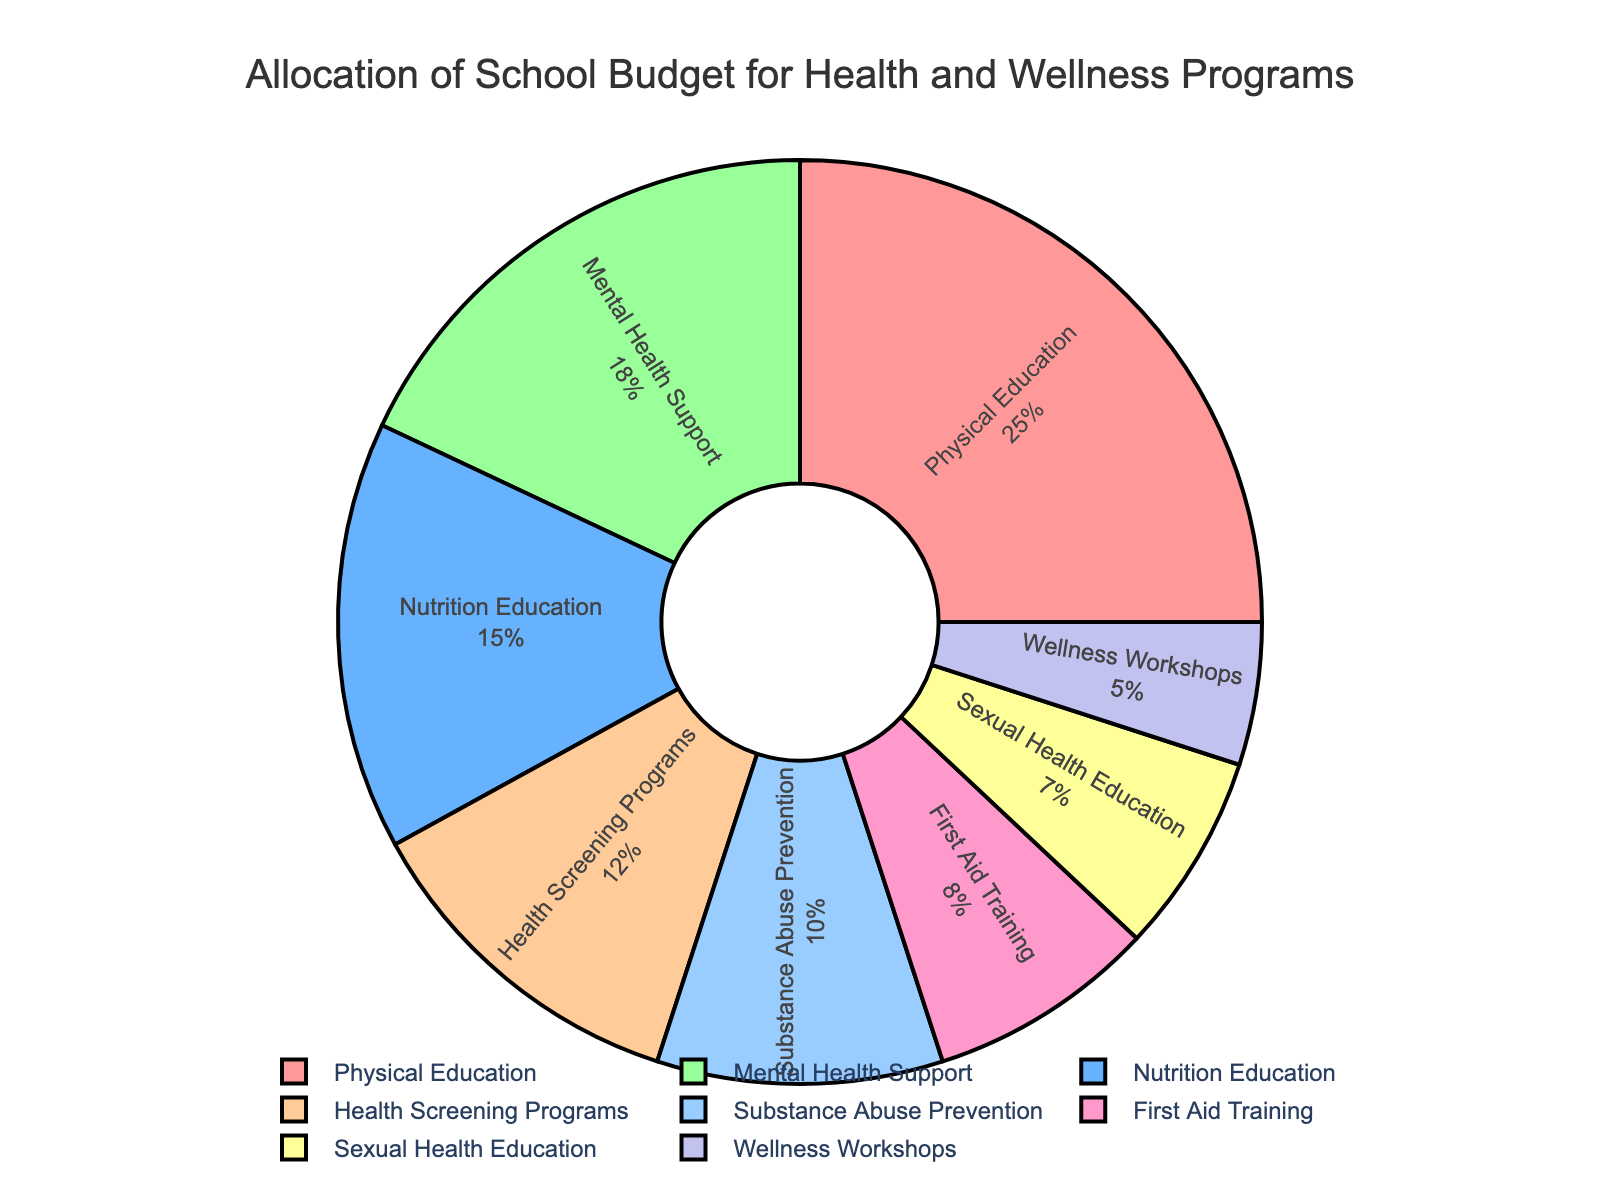What percentage of the school budget is allocated to Mental Health Support and Health Screening Programs combined? Add the percentages for Mental Health Support (18%) and Health Screening Programs (12%) to get the total combined percentage: 18 + 12 = 30
Answer: 30% Which program has the highest allocation of the school budget? By checking the figure, Physical Education has the highest percentage at 25% of the school budget.
Answer: Physical Education How does the allocation for Sexual Health Education compare to the allocation for First Aid Training? First Aid Training has an allocation of 8%, while Sexual Health Education is allocated 7%. Therefore, First Aid Training is allocated a higher percentage than Sexual Health Education.
Answer: First Aid Training has more allocation Which two programs have the smallest allocations in the school budget? Looking at the pie chart, Wellness Workshops (5%) and Sexual Health Education (7%) are the two programs with the smallest allocations.
Answer: Wellness Workshops and Sexual Health Education What is the difference in budget allocation between Nutrition Education and Substance Abuse Prevention? Nutrition Education is allocated 15%, and Substance Abuse Prevention is allocated 10%. The difference is 15 - 10 = 5%.
Answer: 5% How much more percentage is allocated to Physical Education compared to Sexual Health Education? Physical Education is allocated 25% and Sexual Health Education is allocated 7%. The difference is 25 - 7 = 18%.
Answer: 18% If you combined the percentages for First Aid Training and Wellness Workshops, would it be greater or lesser than the allocation for Mental Health Support? First Aid Training (8%) combined with Wellness Workshops (5%) results in a total of 13%. Mental Health Support is allocated 18%, which is greater than the combined total of 13%.
Answer: Lesser Are there more programs with allocations above or below 10%? There are 4 programs above 10% (Physical Education, Nutrition Education, Mental Health Support, and Substance Abuse Prevention) and 4 programs below 10% (Health Screening Programs, First Aid Training, Sexual Health Education, and Wellness Workshops), so both groups are equal in number.
Answer: Equal What is the median percentage allocation among all the programs? The percentages in ascending order are 5, 7, 8, 10, 12, 15, 18, and 25. The median of these numbers (middle value) is the average of the 4th and 5th values: (10 + 12)/2 = 11.
Answer: 11% 